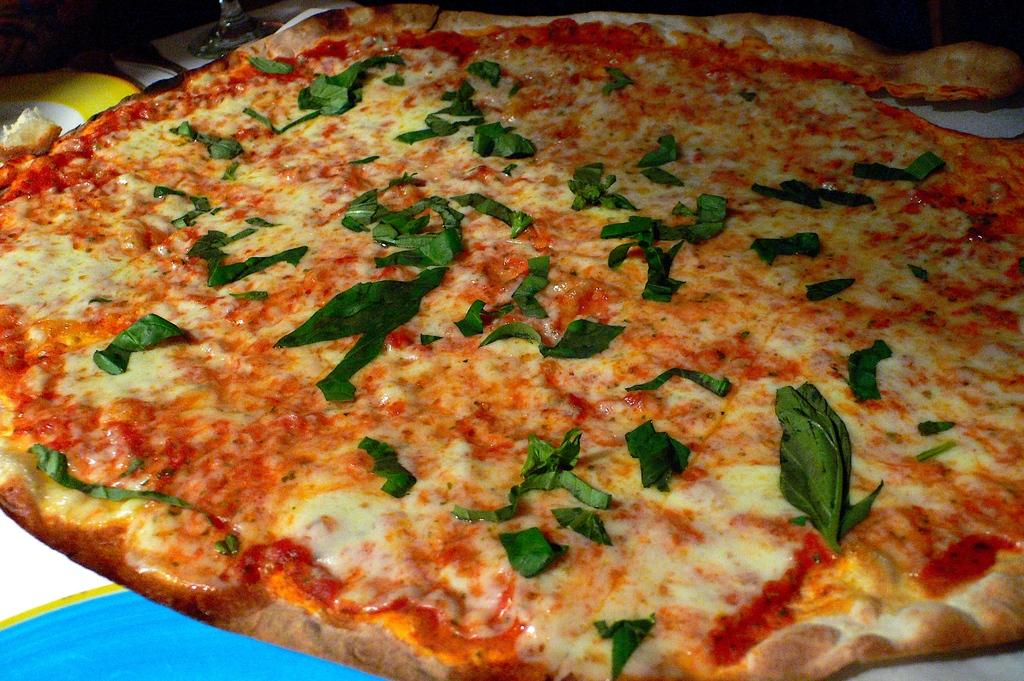What type of food is the main subject of the image? There is a pizza in the image. What additional ingredient can be seen on the pizza? There are curry leaves on the pizza. What type of rock is visible on the pizza in the image? There is no rock visible on the pizza in the image. How does the growth of the curry leaves affect the taste of the pizza? The provided facts do not mention the growth of the curry leaves or their effect on the taste of the pizza. 